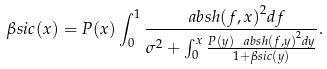Convert formula to latex. <formula><loc_0><loc_0><loc_500><loc_500>\beta s i c ( x ) = P ( x ) \int _ { 0 } ^ { 1 } \frac { \ a b s { h ( f , x ) } ^ { 2 } d f } { \sigma ^ { 2 } + \int _ { 0 } ^ { x } \frac { P ( y ) \ a b s { h ( f , y ) } ^ { 2 } d y } { 1 + \beta s i c ( y ) } } .</formula> 